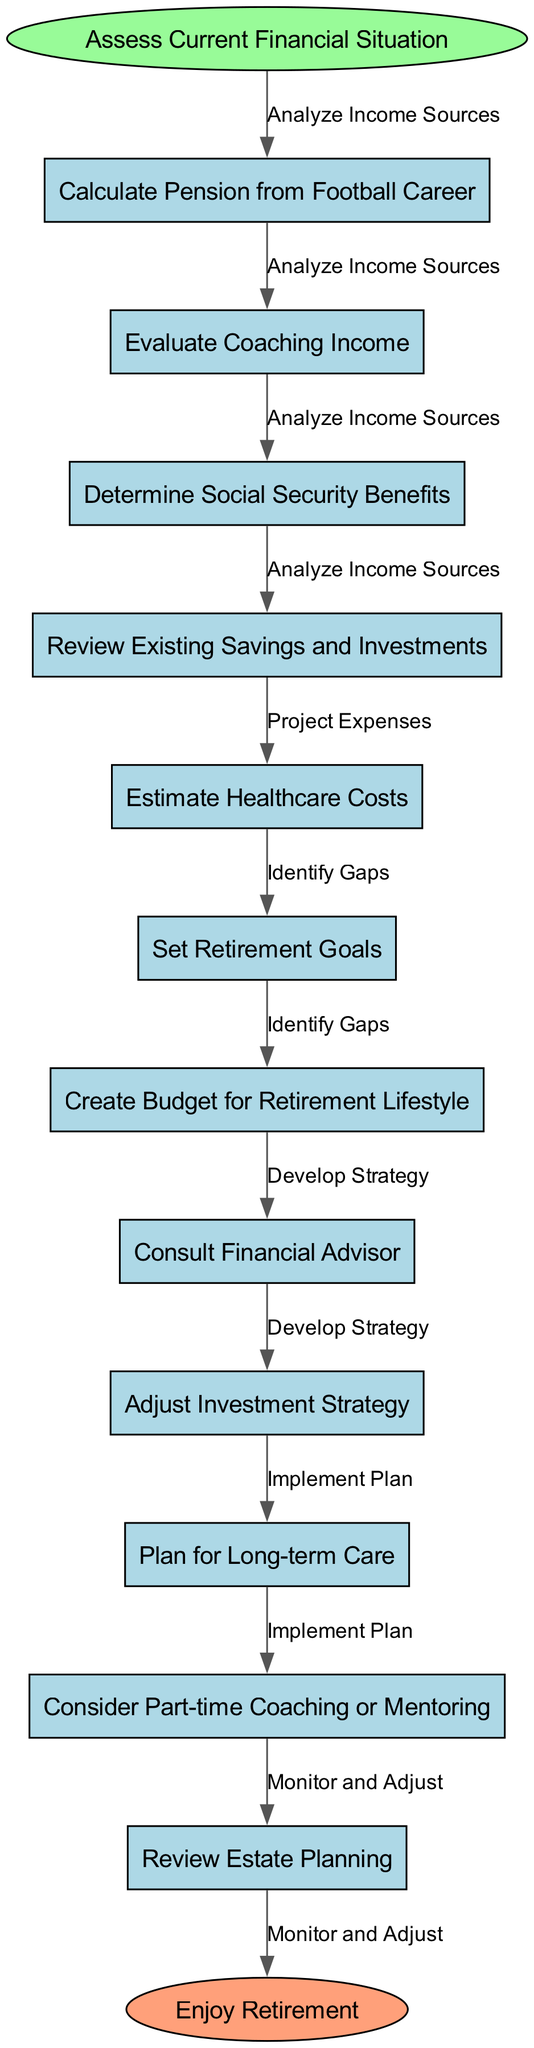What is the start node in the flow chart? The start node is defined in the diagram by the key "startNode". According to the data provided, the start node is "Assess Current Financial Situation".
Answer: Assess Current Financial Situation How many nodes are present in the flow chart? The nodes are listed in the data under "nodes". There are 12 nodes in total if we count both the start and end nodes.
Answer: 12 What is the final node leading to retirement? The final node is specified as "endNode" in the diagram data. Based on the provided information, that node is "Enjoy Retirement".
Answer: Enjoy Retirement What edge connects "Set Retirement Goals" to the next step? The edge that connects "Set Retirement Goals", which is node 6, leads to "Create Budget for Retirement Lifestyle". The edge specified between these nodes is "Develop Strategy".
Answer: Develop Strategy What are the two nodes preceding "Consult Financial Advisor"? The nodes preceding "Consult Financial Advisor" can be traced by moving backward from that node. "Create Budget for Retirement Lifestyle" and "Adjust Investment Strategy" directly connect to this node.
Answer: Create Budget for Retirement Lifestyle, Adjust Investment Strategy What is the first step in projecting retirement financial needs? The first step in the process is detailed in the first edge stemming from the start node, which is to "Analyze Income Sources".
Answer: Analyze Income Sources What action follows after "Implement Plan"? According to the connections in the flow chart, after "Implement Plan", the next action is to "Monitor and Adjust". This establishes a feedback loop for ongoing management.
Answer: Monitor and Adjust What are two important considerations in the retirement planning process? The flow chart includes several nodes that are essential to the process. Two key considerations outlined are "Estimate Healthcare Costs" and "Review Estate Planning", both critical for a secure retirement.
Answer: Estimate Healthcare Costs, Review Estate Planning Which node leads directly to "Plan for Long-term Care"? The node leading directly to "Plan for Long-term Care", which is node 9, is "Adjust Investment Strategy" that precedes it in the flow.
Answer: Adjust Investment Strategy 